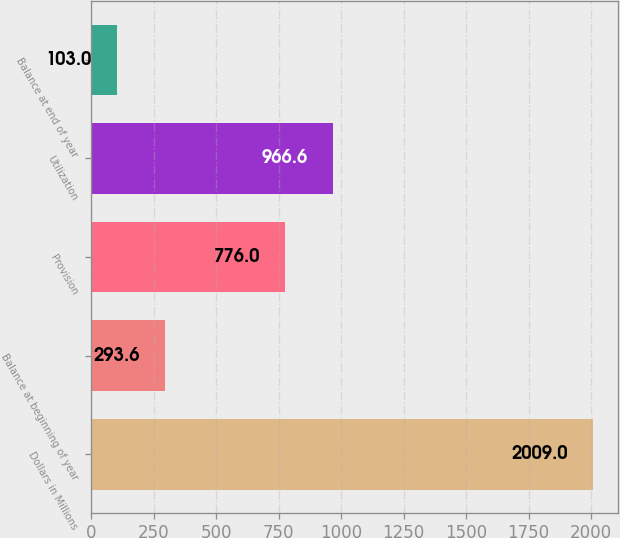Convert chart. <chart><loc_0><loc_0><loc_500><loc_500><bar_chart><fcel>Dollars in Millions<fcel>Balance at beginning of year<fcel>Provision<fcel>Utilization<fcel>Balance at end of year<nl><fcel>2009<fcel>293.6<fcel>776<fcel>966.6<fcel>103<nl></chart> 